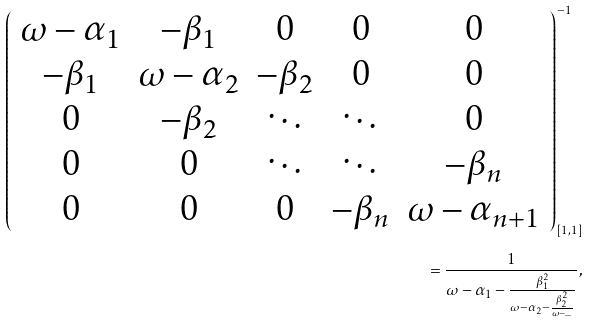Convert formula to latex. <formula><loc_0><loc_0><loc_500><loc_500>\left ( \begin{array} { c c c c c } \omega - \alpha _ { 1 } & - \beta _ { 1 } & 0 & 0 & 0 \\ - \beta _ { 1 } & \omega - \alpha _ { 2 } & - \beta _ { 2 } & 0 & 0 \\ 0 & - \beta _ { 2 } & \ddots & \ddots & 0 \\ 0 & 0 & \ddots & \ddots & - \beta _ { n } \\ 0 & 0 & 0 & - \beta _ { n } & \omega - \alpha _ { n + 1 } \end{array} \right ) ^ { - 1 } _ { [ 1 , 1 ] } \\ = \frac { 1 } { \omega - \alpha _ { 1 } - \frac { \beta _ { 1 } ^ { 2 } } { \omega - \alpha _ { 2 } - \frac { \beta _ { 2 } ^ { 2 } } { \omega - \hdots } } } ,</formula> 